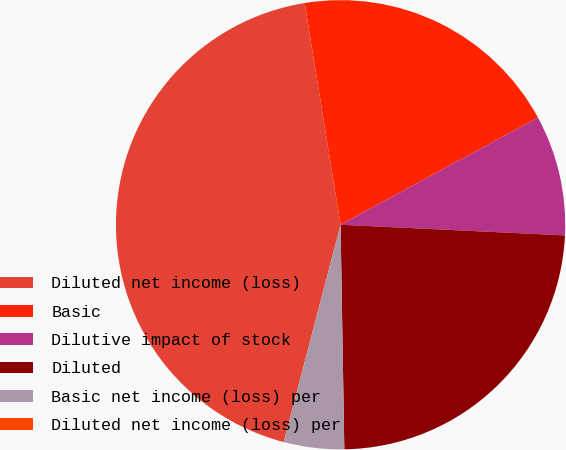Convert chart to OTSL. <chart><loc_0><loc_0><loc_500><loc_500><pie_chart><fcel>Diluted net income (loss)<fcel>Basic<fcel>Dilutive impact of stock<fcel>Diluted<fcel>Basic net income (loss) per<fcel>Diluted net income (loss) per<nl><fcel>43.37%<fcel>19.64%<fcel>8.67%<fcel>23.98%<fcel>4.34%<fcel>0.0%<nl></chart> 